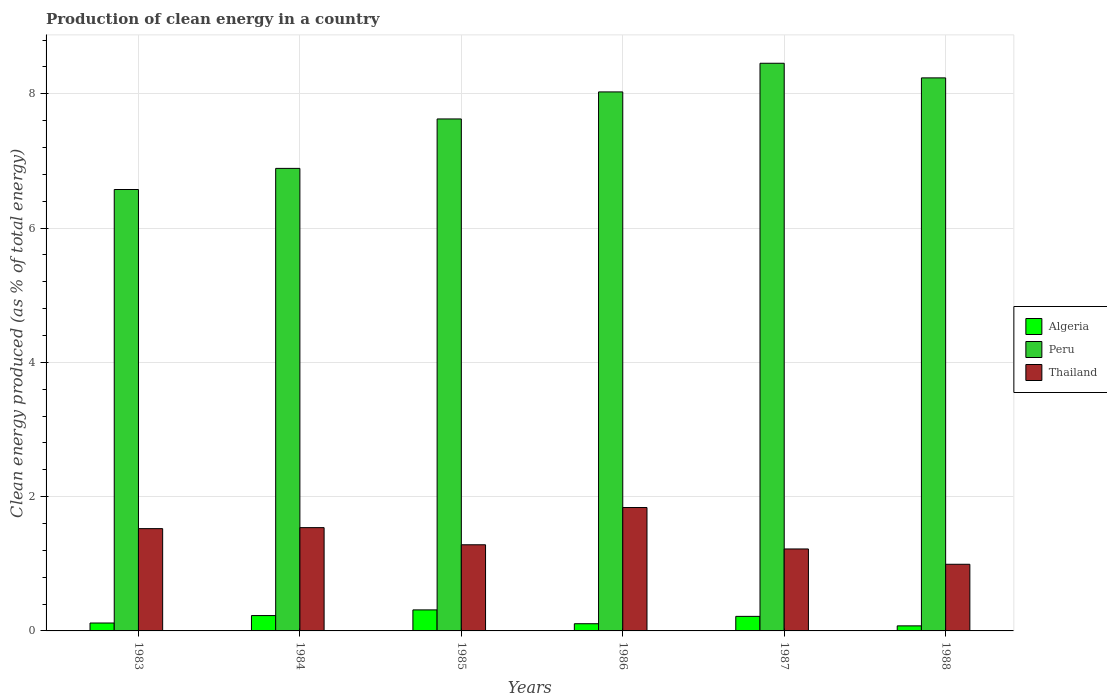How many groups of bars are there?
Your response must be concise. 6. Are the number of bars on each tick of the X-axis equal?
Make the answer very short. Yes. How many bars are there on the 4th tick from the left?
Keep it short and to the point. 3. How many bars are there on the 6th tick from the right?
Your answer should be compact. 3. In how many cases, is the number of bars for a given year not equal to the number of legend labels?
Your answer should be compact. 0. What is the percentage of clean energy produced in Algeria in 1988?
Give a very brief answer. 0.08. Across all years, what is the maximum percentage of clean energy produced in Thailand?
Your response must be concise. 1.84. Across all years, what is the minimum percentage of clean energy produced in Thailand?
Keep it short and to the point. 0.99. In which year was the percentage of clean energy produced in Peru minimum?
Your answer should be compact. 1983. What is the total percentage of clean energy produced in Algeria in the graph?
Your answer should be very brief. 1.06. What is the difference between the percentage of clean energy produced in Peru in 1985 and that in 1986?
Give a very brief answer. -0.4. What is the difference between the percentage of clean energy produced in Thailand in 1986 and the percentage of clean energy produced in Peru in 1983?
Offer a very short reply. -4.74. What is the average percentage of clean energy produced in Thailand per year?
Provide a succinct answer. 1.4. In the year 1984, what is the difference between the percentage of clean energy produced in Peru and percentage of clean energy produced in Thailand?
Provide a short and direct response. 5.35. In how many years, is the percentage of clean energy produced in Algeria greater than 4 %?
Your answer should be compact. 0. What is the ratio of the percentage of clean energy produced in Thailand in 1983 to that in 1988?
Give a very brief answer. 1.53. Is the percentage of clean energy produced in Algeria in 1984 less than that in 1986?
Your answer should be compact. No. What is the difference between the highest and the second highest percentage of clean energy produced in Algeria?
Your answer should be very brief. 0.08. What is the difference between the highest and the lowest percentage of clean energy produced in Thailand?
Keep it short and to the point. 0.85. In how many years, is the percentage of clean energy produced in Peru greater than the average percentage of clean energy produced in Peru taken over all years?
Give a very brief answer. 3. What does the 1st bar from the left in 1988 represents?
Give a very brief answer. Algeria. What does the 3rd bar from the right in 1988 represents?
Your answer should be compact. Algeria. Is it the case that in every year, the sum of the percentage of clean energy produced in Peru and percentage of clean energy produced in Algeria is greater than the percentage of clean energy produced in Thailand?
Provide a succinct answer. Yes. How many bars are there?
Provide a short and direct response. 18. Are the values on the major ticks of Y-axis written in scientific E-notation?
Your answer should be very brief. No. Does the graph contain any zero values?
Keep it short and to the point. No. Where does the legend appear in the graph?
Provide a succinct answer. Center right. How many legend labels are there?
Your answer should be very brief. 3. How are the legend labels stacked?
Your answer should be very brief. Vertical. What is the title of the graph?
Provide a succinct answer. Production of clean energy in a country. What is the label or title of the X-axis?
Your answer should be compact. Years. What is the label or title of the Y-axis?
Provide a succinct answer. Clean energy produced (as % of total energy). What is the Clean energy produced (as % of total energy) of Algeria in 1983?
Provide a succinct answer. 0.12. What is the Clean energy produced (as % of total energy) of Peru in 1983?
Make the answer very short. 6.58. What is the Clean energy produced (as % of total energy) in Thailand in 1983?
Your answer should be compact. 1.52. What is the Clean energy produced (as % of total energy) of Algeria in 1984?
Provide a short and direct response. 0.23. What is the Clean energy produced (as % of total energy) in Peru in 1984?
Give a very brief answer. 6.89. What is the Clean energy produced (as % of total energy) of Thailand in 1984?
Provide a short and direct response. 1.54. What is the Clean energy produced (as % of total energy) in Algeria in 1985?
Your answer should be compact. 0.31. What is the Clean energy produced (as % of total energy) of Peru in 1985?
Offer a very short reply. 7.63. What is the Clean energy produced (as % of total energy) of Thailand in 1985?
Your answer should be compact. 1.28. What is the Clean energy produced (as % of total energy) in Algeria in 1986?
Ensure brevity in your answer.  0.11. What is the Clean energy produced (as % of total energy) of Peru in 1986?
Make the answer very short. 8.03. What is the Clean energy produced (as % of total energy) of Thailand in 1986?
Keep it short and to the point. 1.84. What is the Clean energy produced (as % of total energy) of Algeria in 1987?
Give a very brief answer. 0.22. What is the Clean energy produced (as % of total energy) in Peru in 1987?
Offer a very short reply. 8.46. What is the Clean energy produced (as % of total energy) of Thailand in 1987?
Your answer should be very brief. 1.22. What is the Clean energy produced (as % of total energy) in Algeria in 1988?
Give a very brief answer. 0.08. What is the Clean energy produced (as % of total energy) in Peru in 1988?
Keep it short and to the point. 8.24. What is the Clean energy produced (as % of total energy) in Thailand in 1988?
Your response must be concise. 0.99. Across all years, what is the maximum Clean energy produced (as % of total energy) of Algeria?
Ensure brevity in your answer.  0.31. Across all years, what is the maximum Clean energy produced (as % of total energy) in Peru?
Provide a short and direct response. 8.46. Across all years, what is the maximum Clean energy produced (as % of total energy) in Thailand?
Keep it short and to the point. 1.84. Across all years, what is the minimum Clean energy produced (as % of total energy) in Algeria?
Your answer should be very brief. 0.08. Across all years, what is the minimum Clean energy produced (as % of total energy) of Peru?
Provide a short and direct response. 6.58. Across all years, what is the minimum Clean energy produced (as % of total energy) in Thailand?
Ensure brevity in your answer.  0.99. What is the total Clean energy produced (as % of total energy) in Algeria in the graph?
Offer a terse response. 1.06. What is the total Clean energy produced (as % of total energy) in Peru in the graph?
Your response must be concise. 45.81. What is the total Clean energy produced (as % of total energy) of Thailand in the graph?
Your answer should be very brief. 8.4. What is the difference between the Clean energy produced (as % of total energy) of Algeria in 1983 and that in 1984?
Your answer should be very brief. -0.11. What is the difference between the Clean energy produced (as % of total energy) in Peru in 1983 and that in 1984?
Make the answer very short. -0.31. What is the difference between the Clean energy produced (as % of total energy) of Thailand in 1983 and that in 1984?
Ensure brevity in your answer.  -0.01. What is the difference between the Clean energy produced (as % of total energy) in Algeria in 1983 and that in 1985?
Provide a short and direct response. -0.2. What is the difference between the Clean energy produced (as % of total energy) of Peru in 1983 and that in 1985?
Your answer should be compact. -1.05. What is the difference between the Clean energy produced (as % of total energy) in Thailand in 1983 and that in 1985?
Your response must be concise. 0.24. What is the difference between the Clean energy produced (as % of total energy) of Algeria in 1983 and that in 1986?
Provide a succinct answer. 0.01. What is the difference between the Clean energy produced (as % of total energy) of Peru in 1983 and that in 1986?
Provide a short and direct response. -1.45. What is the difference between the Clean energy produced (as % of total energy) of Thailand in 1983 and that in 1986?
Offer a very short reply. -0.31. What is the difference between the Clean energy produced (as % of total energy) in Algeria in 1983 and that in 1987?
Provide a succinct answer. -0.1. What is the difference between the Clean energy produced (as % of total energy) in Peru in 1983 and that in 1987?
Keep it short and to the point. -1.88. What is the difference between the Clean energy produced (as % of total energy) of Thailand in 1983 and that in 1987?
Give a very brief answer. 0.3. What is the difference between the Clean energy produced (as % of total energy) in Algeria in 1983 and that in 1988?
Provide a succinct answer. 0.04. What is the difference between the Clean energy produced (as % of total energy) in Peru in 1983 and that in 1988?
Your response must be concise. -1.66. What is the difference between the Clean energy produced (as % of total energy) of Thailand in 1983 and that in 1988?
Provide a short and direct response. 0.53. What is the difference between the Clean energy produced (as % of total energy) of Algeria in 1984 and that in 1985?
Offer a terse response. -0.08. What is the difference between the Clean energy produced (as % of total energy) in Peru in 1984 and that in 1985?
Ensure brevity in your answer.  -0.74. What is the difference between the Clean energy produced (as % of total energy) in Thailand in 1984 and that in 1985?
Make the answer very short. 0.26. What is the difference between the Clean energy produced (as % of total energy) of Algeria in 1984 and that in 1986?
Offer a very short reply. 0.12. What is the difference between the Clean energy produced (as % of total energy) of Peru in 1984 and that in 1986?
Provide a succinct answer. -1.14. What is the difference between the Clean energy produced (as % of total energy) of Thailand in 1984 and that in 1986?
Make the answer very short. -0.3. What is the difference between the Clean energy produced (as % of total energy) in Algeria in 1984 and that in 1987?
Give a very brief answer. 0.01. What is the difference between the Clean energy produced (as % of total energy) in Peru in 1984 and that in 1987?
Ensure brevity in your answer.  -1.57. What is the difference between the Clean energy produced (as % of total energy) of Thailand in 1984 and that in 1987?
Keep it short and to the point. 0.32. What is the difference between the Clean energy produced (as % of total energy) in Algeria in 1984 and that in 1988?
Your answer should be very brief. 0.15. What is the difference between the Clean energy produced (as % of total energy) of Peru in 1984 and that in 1988?
Provide a succinct answer. -1.35. What is the difference between the Clean energy produced (as % of total energy) in Thailand in 1984 and that in 1988?
Your answer should be compact. 0.55. What is the difference between the Clean energy produced (as % of total energy) in Algeria in 1985 and that in 1986?
Your answer should be compact. 0.21. What is the difference between the Clean energy produced (as % of total energy) of Peru in 1985 and that in 1986?
Keep it short and to the point. -0.4. What is the difference between the Clean energy produced (as % of total energy) of Thailand in 1985 and that in 1986?
Give a very brief answer. -0.56. What is the difference between the Clean energy produced (as % of total energy) in Algeria in 1985 and that in 1987?
Keep it short and to the point. 0.1. What is the difference between the Clean energy produced (as % of total energy) of Peru in 1985 and that in 1987?
Make the answer very short. -0.83. What is the difference between the Clean energy produced (as % of total energy) in Thailand in 1985 and that in 1987?
Give a very brief answer. 0.06. What is the difference between the Clean energy produced (as % of total energy) of Algeria in 1985 and that in 1988?
Provide a succinct answer. 0.24. What is the difference between the Clean energy produced (as % of total energy) in Peru in 1985 and that in 1988?
Your answer should be compact. -0.61. What is the difference between the Clean energy produced (as % of total energy) of Thailand in 1985 and that in 1988?
Provide a succinct answer. 0.29. What is the difference between the Clean energy produced (as % of total energy) of Algeria in 1986 and that in 1987?
Ensure brevity in your answer.  -0.11. What is the difference between the Clean energy produced (as % of total energy) in Peru in 1986 and that in 1987?
Offer a terse response. -0.43. What is the difference between the Clean energy produced (as % of total energy) in Thailand in 1986 and that in 1987?
Ensure brevity in your answer.  0.62. What is the difference between the Clean energy produced (as % of total energy) in Algeria in 1986 and that in 1988?
Your answer should be very brief. 0.03. What is the difference between the Clean energy produced (as % of total energy) of Peru in 1986 and that in 1988?
Provide a succinct answer. -0.21. What is the difference between the Clean energy produced (as % of total energy) in Thailand in 1986 and that in 1988?
Make the answer very short. 0.85. What is the difference between the Clean energy produced (as % of total energy) in Algeria in 1987 and that in 1988?
Keep it short and to the point. 0.14. What is the difference between the Clean energy produced (as % of total energy) in Peru in 1987 and that in 1988?
Ensure brevity in your answer.  0.22. What is the difference between the Clean energy produced (as % of total energy) of Thailand in 1987 and that in 1988?
Offer a terse response. 0.23. What is the difference between the Clean energy produced (as % of total energy) of Algeria in 1983 and the Clean energy produced (as % of total energy) of Peru in 1984?
Keep it short and to the point. -6.77. What is the difference between the Clean energy produced (as % of total energy) in Algeria in 1983 and the Clean energy produced (as % of total energy) in Thailand in 1984?
Your answer should be very brief. -1.42. What is the difference between the Clean energy produced (as % of total energy) of Peru in 1983 and the Clean energy produced (as % of total energy) of Thailand in 1984?
Your answer should be very brief. 5.04. What is the difference between the Clean energy produced (as % of total energy) of Algeria in 1983 and the Clean energy produced (as % of total energy) of Peru in 1985?
Offer a very short reply. -7.51. What is the difference between the Clean energy produced (as % of total energy) in Algeria in 1983 and the Clean energy produced (as % of total energy) in Thailand in 1985?
Provide a short and direct response. -1.17. What is the difference between the Clean energy produced (as % of total energy) in Peru in 1983 and the Clean energy produced (as % of total energy) in Thailand in 1985?
Provide a succinct answer. 5.29. What is the difference between the Clean energy produced (as % of total energy) in Algeria in 1983 and the Clean energy produced (as % of total energy) in Peru in 1986?
Offer a very short reply. -7.91. What is the difference between the Clean energy produced (as % of total energy) in Algeria in 1983 and the Clean energy produced (as % of total energy) in Thailand in 1986?
Provide a short and direct response. -1.72. What is the difference between the Clean energy produced (as % of total energy) in Peru in 1983 and the Clean energy produced (as % of total energy) in Thailand in 1986?
Provide a short and direct response. 4.74. What is the difference between the Clean energy produced (as % of total energy) of Algeria in 1983 and the Clean energy produced (as % of total energy) of Peru in 1987?
Make the answer very short. -8.34. What is the difference between the Clean energy produced (as % of total energy) in Algeria in 1983 and the Clean energy produced (as % of total energy) in Thailand in 1987?
Provide a succinct answer. -1.1. What is the difference between the Clean energy produced (as % of total energy) in Peru in 1983 and the Clean energy produced (as % of total energy) in Thailand in 1987?
Your answer should be very brief. 5.35. What is the difference between the Clean energy produced (as % of total energy) of Algeria in 1983 and the Clean energy produced (as % of total energy) of Peru in 1988?
Provide a succinct answer. -8.12. What is the difference between the Clean energy produced (as % of total energy) of Algeria in 1983 and the Clean energy produced (as % of total energy) of Thailand in 1988?
Provide a succinct answer. -0.87. What is the difference between the Clean energy produced (as % of total energy) of Peru in 1983 and the Clean energy produced (as % of total energy) of Thailand in 1988?
Provide a short and direct response. 5.58. What is the difference between the Clean energy produced (as % of total energy) of Algeria in 1984 and the Clean energy produced (as % of total energy) of Peru in 1985?
Ensure brevity in your answer.  -7.4. What is the difference between the Clean energy produced (as % of total energy) of Algeria in 1984 and the Clean energy produced (as % of total energy) of Thailand in 1985?
Provide a short and direct response. -1.05. What is the difference between the Clean energy produced (as % of total energy) in Peru in 1984 and the Clean energy produced (as % of total energy) in Thailand in 1985?
Your answer should be compact. 5.61. What is the difference between the Clean energy produced (as % of total energy) in Algeria in 1984 and the Clean energy produced (as % of total energy) in Peru in 1986?
Offer a very short reply. -7.8. What is the difference between the Clean energy produced (as % of total energy) in Algeria in 1984 and the Clean energy produced (as % of total energy) in Thailand in 1986?
Your answer should be very brief. -1.61. What is the difference between the Clean energy produced (as % of total energy) of Peru in 1984 and the Clean energy produced (as % of total energy) of Thailand in 1986?
Your response must be concise. 5.05. What is the difference between the Clean energy produced (as % of total energy) in Algeria in 1984 and the Clean energy produced (as % of total energy) in Peru in 1987?
Ensure brevity in your answer.  -8.23. What is the difference between the Clean energy produced (as % of total energy) in Algeria in 1984 and the Clean energy produced (as % of total energy) in Thailand in 1987?
Your answer should be compact. -0.99. What is the difference between the Clean energy produced (as % of total energy) of Peru in 1984 and the Clean energy produced (as % of total energy) of Thailand in 1987?
Offer a very short reply. 5.67. What is the difference between the Clean energy produced (as % of total energy) of Algeria in 1984 and the Clean energy produced (as % of total energy) of Peru in 1988?
Provide a short and direct response. -8.01. What is the difference between the Clean energy produced (as % of total energy) of Algeria in 1984 and the Clean energy produced (as % of total energy) of Thailand in 1988?
Provide a succinct answer. -0.76. What is the difference between the Clean energy produced (as % of total energy) of Peru in 1984 and the Clean energy produced (as % of total energy) of Thailand in 1988?
Make the answer very short. 5.9. What is the difference between the Clean energy produced (as % of total energy) of Algeria in 1985 and the Clean energy produced (as % of total energy) of Peru in 1986?
Offer a very short reply. -7.72. What is the difference between the Clean energy produced (as % of total energy) in Algeria in 1985 and the Clean energy produced (as % of total energy) in Thailand in 1986?
Provide a succinct answer. -1.52. What is the difference between the Clean energy produced (as % of total energy) of Peru in 1985 and the Clean energy produced (as % of total energy) of Thailand in 1986?
Your answer should be compact. 5.79. What is the difference between the Clean energy produced (as % of total energy) of Algeria in 1985 and the Clean energy produced (as % of total energy) of Peru in 1987?
Give a very brief answer. -8.14. What is the difference between the Clean energy produced (as % of total energy) in Algeria in 1985 and the Clean energy produced (as % of total energy) in Thailand in 1987?
Offer a terse response. -0.91. What is the difference between the Clean energy produced (as % of total energy) of Peru in 1985 and the Clean energy produced (as % of total energy) of Thailand in 1987?
Keep it short and to the point. 6.41. What is the difference between the Clean energy produced (as % of total energy) in Algeria in 1985 and the Clean energy produced (as % of total energy) in Peru in 1988?
Provide a short and direct response. -7.92. What is the difference between the Clean energy produced (as % of total energy) in Algeria in 1985 and the Clean energy produced (as % of total energy) in Thailand in 1988?
Your answer should be compact. -0.68. What is the difference between the Clean energy produced (as % of total energy) in Peru in 1985 and the Clean energy produced (as % of total energy) in Thailand in 1988?
Provide a short and direct response. 6.63. What is the difference between the Clean energy produced (as % of total energy) of Algeria in 1986 and the Clean energy produced (as % of total energy) of Peru in 1987?
Make the answer very short. -8.35. What is the difference between the Clean energy produced (as % of total energy) in Algeria in 1986 and the Clean energy produced (as % of total energy) in Thailand in 1987?
Your response must be concise. -1.11. What is the difference between the Clean energy produced (as % of total energy) of Peru in 1986 and the Clean energy produced (as % of total energy) of Thailand in 1987?
Provide a succinct answer. 6.81. What is the difference between the Clean energy produced (as % of total energy) in Algeria in 1986 and the Clean energy produced (as % of total energy) in Peru in 1988?
Make the answer very short. -8.13. What is the difference between the Clean energy produced (as % of total energy) of Algeria in 1986 and the Clean energy produced (as % of total energy) of Thailand in 1988?
Provide a short and direct response. -0.89. What is the difference between the Clean energy produced (as % of total energy) of Peru in 1986 and the Clean energy produced (as % of total energy) of Thailand in 1988?
Give a very brief answer. 7.04. What is the difference between the Clean energy produced (as % of total energy) in Algeria in 1987 and the Clean energy produced (as % of total energy) in Peru in 1988?
Your response must be concise. -8.02. What is the difference between the Clean energy produced (as % of total energy) of Algeria in 1987 and the Clean energy produced (as % of total energy) of Thailand in 1988?
Provide a short and direct response. -0.78. What is the difference between the Clean energy produced (as % of total energy) in Peru in 1987 and the Clean energy produced (as % of total energy) in Thailand in 1988?
Give a very brief answer. 7.46. What is the average Clean energy produced (as % of total energy) of Algeria per year?
Provide a short and direct response. 0.18. What is the average Clean energy produced (as % of total energy) in Peru per year?
Keep it short and to the point. 7.64. What is the average Clean energy produced (as % of total energy) in Thailand per year?
Make the answer very short. 1.4. In the year 1983, what is the difference between the Clean energy produced (as % of total energy) in Algeria and Clean energy produced (as % of total energy) in Peru?
Your response must be concise. -6.46. In the year 1983, what is the difference between the Clean energy produced (as % of total energy) of Algeria and Clean energy produced (as % of total energy) of Thailand?
Make the answer very short. -1.41. In the year 1983, what is the difference between the Clean energy produced (as % of total energy) in Peru and Clean energy produced (as % of total energy) in Thailand?
Ensure brevity in your answer.  5.05. In the year 1984, what is the difference between the Clean energy produced (as % of total energy) in Algeria and Clean energy produced (as % of total energy) in Peru?
Keep it short and to the point. -6.66. In the year 1984, what is the difference between the Clean energy produced (as % of total energy) in Algeria and Clean energy produced (as % of total energy) in Thailand?
Provide a succinct answer. -1.31. In the year 1984, what is the difference between the Clean energy produced (as % of total energy) in Peru and Clean energy produced (as % of total energy) in Thailand?
Your answer should be compact. 5.35. In the year 1985, what is the difference between the Clean energy produced (as % of total energy) of Algeria and Clean energy produced (as % of total energy) of Peru?
Provide a succinct answer. -7.31. In the year 1985, what is the difference between the Clean energy produced (as % of total energy) in Algeria and Clean energy produced (as % of total energy) in Thailand?
Your answer should be compact. -0.97. In the year 1985, what is the difference between the Clean energy produced (as % of total energy) in Peru and Clean energy produced (as % of total energy) in Thailand?
Your answer should be very brief. 6.34. In the year 1986, what is the difference between the Clean energy produced (as % of total energy) in Algeria and Clean energy produced (as % of total energy) in Peru?
Offer a terse response. -7.92. In the year 1986, what is the difference between the Clean energy produced (as % of total energy) of Algeria and Clean energy produced (as % of total energy) of Thailand?
Offer a terse response. -1.73. In the year 1986, what is the difference between the Clean energy produced (as % of total energy) of Peru and Clean energy produced (as % of total energy) of Thailand?
Your answer should be very brief. 6.19. In the year 1987, what is the difference between the Clean energy produced (as % of total energy) of Algeria and Clean energy produced (as % of total energy) of Peru?
Offer a very short reply. -8.24. In the year 1987, what is the difference between the Clean energy produced (as % of total energy) in Algeria and Clean energy produced (as % of total energy) in Thailand?
Offer a terse response. -1. In the year 1987, what is the difference between the Clean energy produced (as % of total energy) in Peru and Clean energy produced (as % of total energy) in Thailand?
Your answer should be very brief. 7.23. In the year 1988, what is the difference between the Clean energy produced (as % of total energy) of Algeria and Clean energy produced (as % of total energy) of Peru?
Provide a short and direct response. -8.16. In the year 1988, what is the difference between the Clean energy produced (as % of total energy) of Algeria and Clean energy produced (as % of total energy) of Thailand?
Your response must be concise. -0.92. In the year 1988, what is the difference between the Clean energy produced (as % of total energy) in Peru and Clean energy produced (as % of total energy) in Thailand?
Your answer should be very brief. 7.24. What is the ratio of the Clean energy produced (as % of total energy) of Algeria in 1983 to that in 1984?
Keep it short and to the point. 0.52. What is the ratio of the Clean energy produced (as % of total energy) in Peru in 1983 to that in 1984?
Ensure brevity in your answer.  0.95. What is the ratio of the Clean energy produced (as % of total energy) of Thailand in 1983 to that in 1984?
Keep it short and to the point. 0.99. What is the ratio of the Clean energy produced (as % of total energy) of Algeria in 1983 to that in 1985?
Your response must be concise. 0.38. What is the ratio of the Clean energy produced (as % of total energy) of Peru in 1983 to that in 1985?
Make the answer very short. 0.86. What is the ratio of the Clean energy produced (as % of total energy) of Thailand in 1983 to that in 1985?
Provide a succinct answer. 1.19. What is the ratio of the Clean energy produced (as % of total energy) in Algeria in 1983 to that in 1986?
Provide a short and direct response. 1.1. What is the ratio of the Clean energy produced (as % of total energy) of Peru in 1983 to that in 1986?
Ensure brevity in your answer.  0.82. What is the ratio of the Clean energy produced (as % of total energy) in Thailand in 1983 to that in 1986?
Make the answer very short. 0.83. What is the ratio of the Clean energy produced (as % of total energy) in Algeria in 1983 to that in 1987?
Keep it short and to the point. 0.54. What is the ratio of the Clean energy produced (as % of total energy) of Peru in 1983 to that in 1987?
Make the answer very short. 0.78. What is the ratio of the Clean energy produced (as % of total energy) of Thailand in 1983 to that in 1987?
Your answer should be compact. 1.25. What is the ratio of the Clean energy produced (as % of total energy) in Algeria in 1983 to that in 1988?
Offer a very short reply. 1.56. What is the ratio of the Clean energy produced (as % of total energy) in Peru in 1983 to that in 1988?
Offer a terse response. 0.8. What is the ratio of the Clean energy produced (as % of total energy) in Thailand in 1983 to that in 1988?
Offer a very short reply. 1.53. What is the ratio of the Clean energy produced (as % of total energy) in Algeria in 1984 to that in 1985?
Your answer should be compact. 0.73. What is the ratio of the Clean energy produced (as % of total energy) of Peru in 1984 to that in 1985?
Your response must be concise. 0.9. What is the ratio of the Clean energy produced (as % of total energy) in Thailand in 1984 to that in 1985?
Your answer should be compact. 1.2. What is the ratio of the Clean energy produced (as % of total energy) of Algeria in 1984 to that in 1986?
Ensure brevity in your answer.  2.13. What is the ratio of the Clean energy produced (as % of total energy) of Peru in 1984 to that in 1986?
Offer a terse response. 0.86. What is the ratio of the Clean energy produced (as % of total energy) in Thailand in 1984 to that in 1986?
Provide a short and direct response. 0.84. What is the ratio of the Clean energy produced (as % of total energy) in Algeria in 1984 to that in 1987?
Make the answer very short. 1.05. What is the ratio of the Clean energy produced (as % of total energy) of Peru in 1984 to that in 1987?
Your answer should be compact. 0.81. What is the ratio of the Clean energy produced (as % of total energy) in Thailand in 1984 to that in 1987?
Keep it short and to the point. 1.26. What is the ratio of the Clean energy produced (as % of total energy) in Algeria in 1984 to that in 1988?
Offer a very short reply. 3.04. What is the ratio of the Clean energy produced (as % of total energy) of Peru in 1984 to that in 1988?
Your response must be concise. 0.84. What is the ratio of the Clean energy produced (as % of total energy) in Thailand in 1984 to that in 1988?
Offer a terse response. 1.55. What is the ratio of the Clean energy produced (as % of total energy) in Algeria in 1985 to that in 1986?
Give a very brief answer. 2.92. What is the ratio of the Clean energy produced (as % of total energy) of Peru in 1985 to that in 1986?
Your answer should be very brief. 0.95. What is the ratio of the Clean energy produced (as % of total energy) of Thailand in 1985 to that in 1986?
Your response must be concise. 0.7. What is the ratio of the Clean energy produced (as % of total energy) in Algeria in 1985 to that in 1987?
Offer a terse response. 1.44. What is the ratio of the Clean energy produced (as % of total energy) in Peru in 1985 to that in 1987?
Offer a very short reply. 0.9. What is the ratio of the Clean energy produced (as % of total energy) in Thailand in 1985 to that in 1987?
Offer a very short reply. 1.05. What is the ratio of the Clean energy produced (as % of total energy) of Algeria in 1985 to that in 1988?
Give a very brief answer. 4.16. What is the ratio of the Clean energy produced (as % of total energy) of Peru in 1985 to that in 1988?
Make the answer very short. 0.93. What is the ratio of the Clean energy produced (as % of total energy) of Thailand in 1985 to that in 1988?
Your answer should be very brief. 1.29. What is the ratio of the Clean energy produced (as % of total energy) in Algeria in 1986 to that in 1987?
Your answer should be compact. 0.49. What is the ratio of the Clean energy produced (as % of total energy) of Peru in 1986 to that in 1987?
Keep it short and to the point. 0.95. What is the ratio of the Clean energy produced (as % of total energy) in Thailand in 1986 to that in 1987?
Ensure brevity in your answer.  1.51. What is the ratio of the Clean energy produced (as % of total energy) in Algeria in 1986 to that in 1988?
Give a very brief answer. 1.42. What is the ratio of the Clean energy produced (as % of total energy) in Peru in 1986 to that in 1988?
Keep it short and to the point. 0.97. What is the ratio of the Clean energy produced (as % of total energy) in Thailand in 1986 to that in 1988?
Provide a succinct answer. 1.85. What is the ratio of the Clean energy produced (as % of total energy) of Algeria in 1987 to that in 1988?
Offer a terse response. 2.88. What is the ratio of the Clean energy produced (as % of total energy) of Peru in 1987 to that in 1988?
Ensure brevity in your answer.  1.03. What is the ratio of the Clean energy produced (as % of total energy) in Thailand in 1987 to that in 1988?
Your response must be concise. 1.23. What is the difference between the highest and the second highest Clean energy produced (as % of total energy) of Algeria?
Your response must be concise. 0.08. What is the difference between the highest and the second highest Clean energy produced (as % of total energy) in Peru?
Provide a succinct answer. 0.22. What is the difference between the highest and the second highest Clean energy produced (as % of total energy) in Thailand?
Ensure brevity in your answer.  0.3. What is the difference between the highest and the lowest Clean energy produced (as % of total energy) of Algeria?
Your response must be concise. 0.24. What is the difference between the highest and the lowest Clean energy produced (as % of total energy) of Peru?
Ensure brevity in your answer.  1.88. What is the difference between the highest and the lowest Clean energy produced (as % of total energy) of Thailand?
Provide a succinct answer. 0.85. 